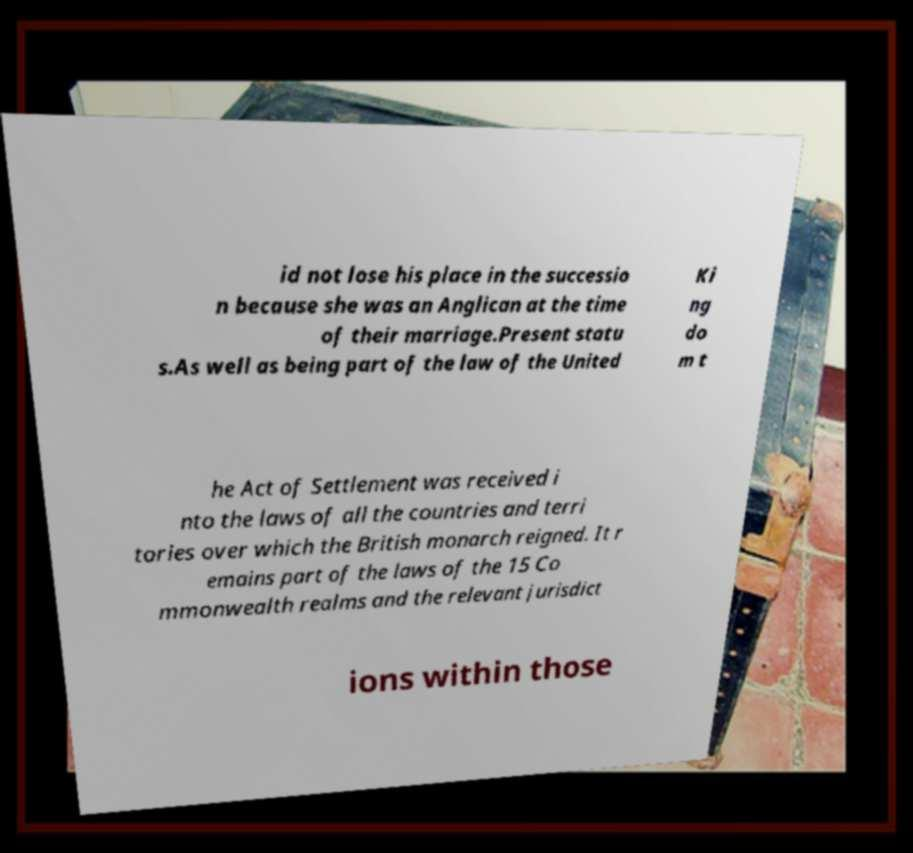I need the written content from this picture converted into text. Can you do that? id not lose his place in the successio n because she was an Anglican at the time of their marriage.Present statu s.As well as being part of the law of the United Ki ng do m t he Act of Settlement was received i nto the laws of all the countries and terri tories over which the British monarch reigned. It r emains part of the laws of the 15 Co mmonwealth realms and the relevant jurisdict ions within those 